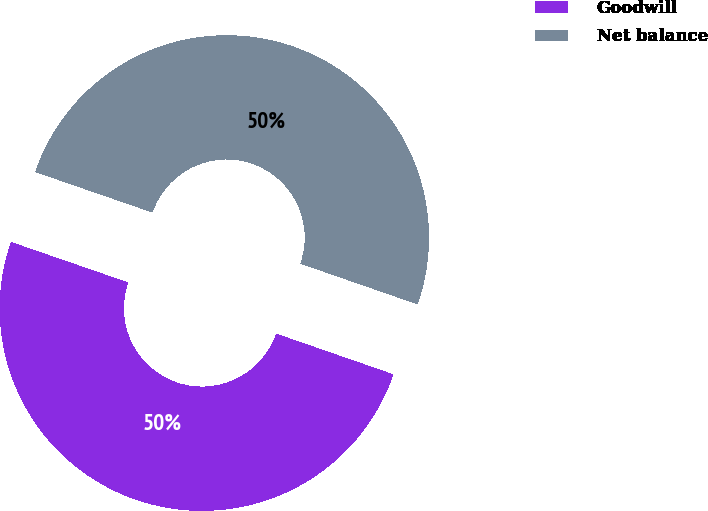Convert chart to OTSL. <chart><loc_0><loc_0><loc_500><loc_500><pie_chart><fcel>Goodwill<fcel>Net balance<nl><fcel>49.98%<fcel>50.02%<nl></chart> 